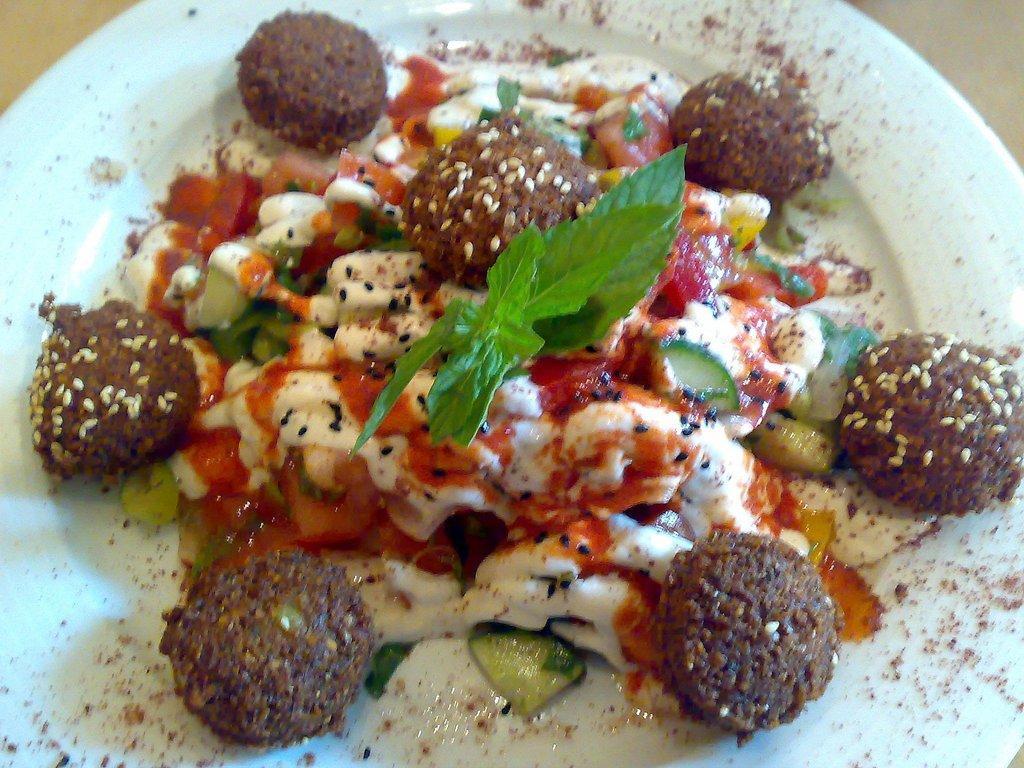Please provide a concise description of this image. This image consists of food which is on the plate in the center. 